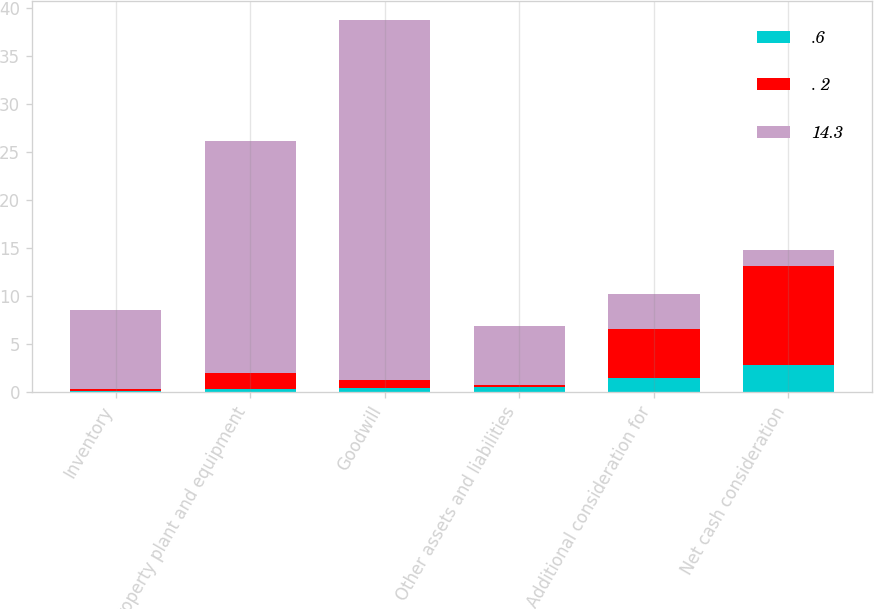Convert chart. <chart><loc_0><loc_0><loc_500><loc_500><stacked_bar_chart><ecel><fcel>Inventory<fcel>Property plant and equipment<fcel>Goodwill<fcel>Other assets and liabilities<fcel>Additional consideration for<fcel>Net cash consideration<nl><fcel>.6<fcel>0.1<fcel>0.3<fcel>0.4<fcel>0.5<fcel>1.5<fcel>2.8<nl><fcel>. 2<fcel>0.2<fcel>1.7<fcel>0.9<fcel>0.2<fcel>5.1<fcel>10.3<nl><fcel>14.3<fcel>8.3<fcel>24.2<fcel>37.5<fcel>6.2<fcel>3.6<fcel>1.7<nl></chart> 